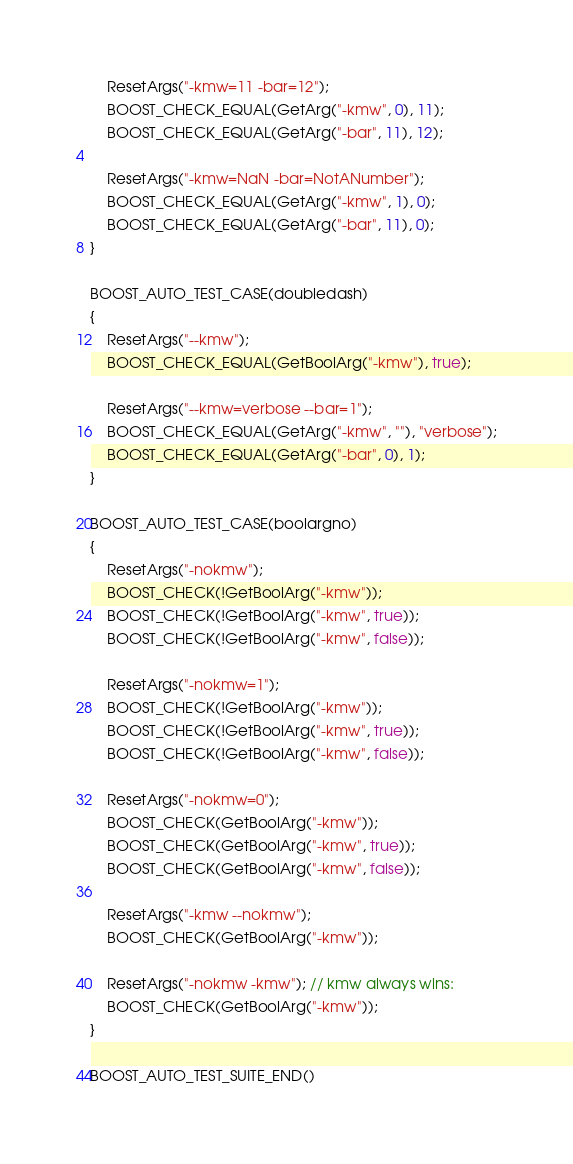Convert code to text. <code><loc_0><loc_0><loc_500><loc_500><_C++_>    ResetArgs("-kmw=11 -bar=12");
    BOOST_CHECK_EQUAL(GetArg("-kmw", 0), 11);
    BOOST_CHECK_EQUAL(GetArg("-bar", 11), 12);

    ResetArgs("-kmw=NaN -bar=NotANumber");
    BOOST_CHECK_EQUAL(GetArg("-kmw", 1), 0);
    BOOST_CHECK_EQUAL(GetArg("-bar", 11), 0);
}

BOOST_AUTO_TEST_CASE(doubledash)
{
    ResetArgs("--kmw");
    BOOST_CHECK_EQUAL(GetBoolArg("-kmw"), true);

    ResetArgs("--kmw=verbose --bar=1");
    BOOST_CHECK_EQUAL(GetArg("-kmw", ""), "verbose");
    BOOST_CHECK_EQUAL(GetArg("-bar", 0), 1);
}

BOOST_AUTO_TEST_CASE(boolargno)
{
    ResetArgs("-nokmw");
    BOOST_CHECK(!GetBoolArg("-kmw"));
    BOOST_CHECK(!GetBoolArg("-kmw", true));
    BOOST_CHECK(!GetBoolArg("-kmw", false));

    ResetArgs("-nokmw=1");
    BOOST_CHECK(!GetBoolArg("-kmw"));
    BOOST_CHECK(!GetBoolArg("-kmw", true));
    BOOST_CHECK(!GetBoolArg("-kmw", false));

    ResetArgs("-nokmw=0");
    BOOST_CHECK(GetBoolArg("-kmw"));
    BOOST_CHECK(GetBoolArg("-kmw", true));
    BOOST_CHECK(GetBoolArg("-kmw", false));

    ResetArgs("-kmw --nokmw");
    BOOST_CHECK(GetBoolArg("-kmw"));

    ResetArgs("-nokmw -kmw"); // kmw always wins:
    BOOST_CHECK(GetBoolArg("-kmw"));
}

BOOST_AUTO_TEST_SUITE_END()
</code> 